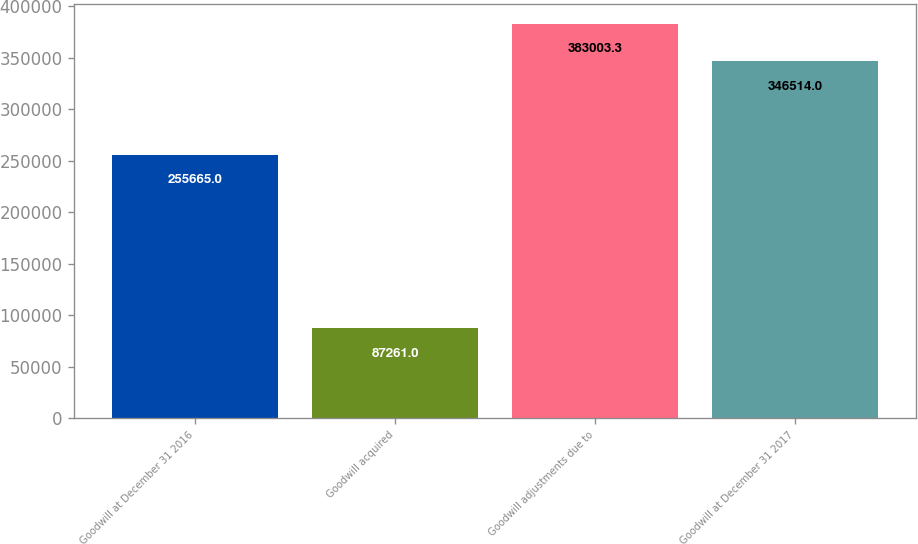Convert chart to OTSL. <chart><loc_0><loc_0><loc_500><loc_500><bar_chart><fcel>Goodwill at December 31 2016<fcel>Goodwill acquired<fcel>Goodwill adjustments due to<fcel>Goodwill at December 31 2017<nl><fcel>255665<fcel>87261<fcel>383003<fcel>346514<nl></chart> 